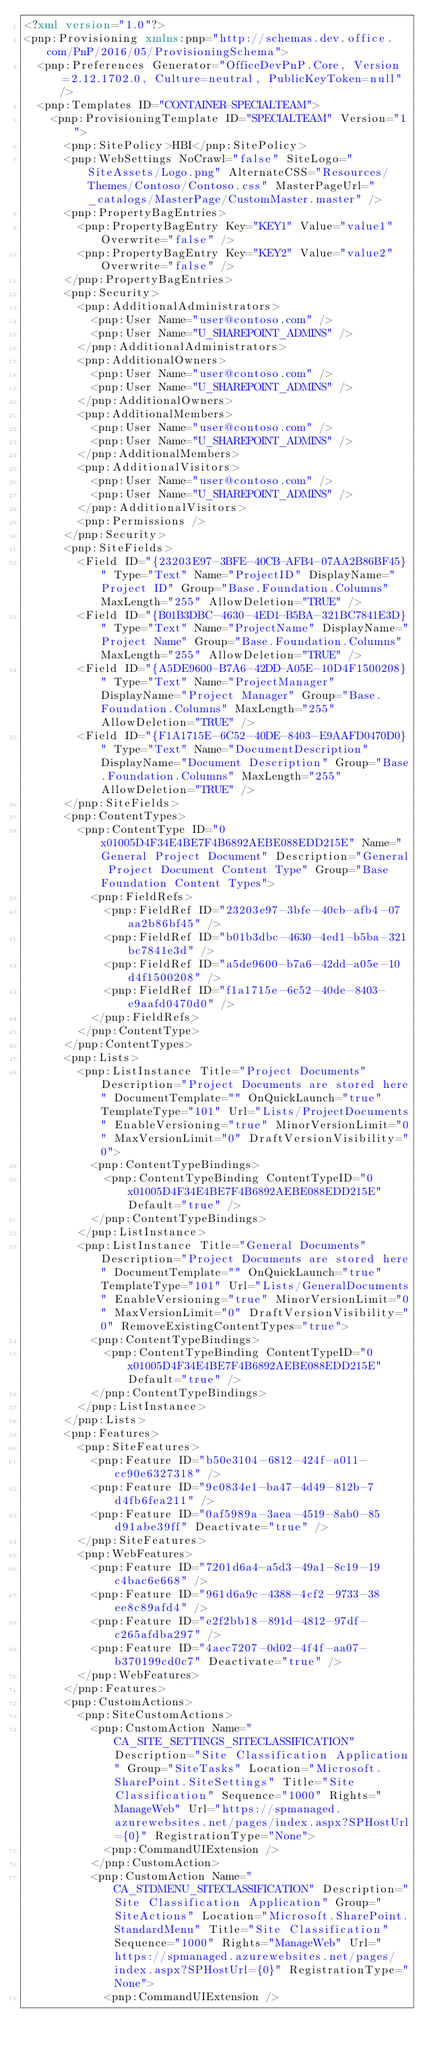<code> <loc_0><loc_0><loc_500><loc_500><_XML_><?xml version="1.0"?>
<pnp:Provisioning xmlns:pnp="http://schemas.dev.office.com/PnP/2016/05/ProvisioningSchema">
  <pnp:Preferences Generator="OfficeDevPnP.Core, Version=2.12.1702.0, Culture=neutral, PublicKeyToken=null" />
  <pnp:Templates ID="CONTAINER-SPECIALTEAM">
    <pnp:ProvisioningTemplate ID="SPECIALTEAM" Version="1">
      <pnp:SitePolicy>HBI</pnp:SitePolicy>
      <pnp:WebSettings NoCrawl="false" SiteLogo="SiteAssets/Logo.png" AlternateCSS="Resources/Themes/Contoso/Contoso.css" MasterPageUrl="_catalogs/MasterPage/CustomMaster.master" />
      <pnp:PropertyBagEntries>
        <pnp:PropertyBagEntry Key="KEY1" Value="value1" Overwrite="false" />
        <pnp:PropertyBagEntry Key="KEY2" Value="value2" Overwrite="false" />
      </pnp:PropertyBagEntries>
      <pnp:Security>
        <pnp:AdditionalAdministrators>
          <pnp:User Name="user@contoso.com" />
          <pnp:User Name="U_SHAREPOINT_ADMINS" />
        </pnp:AdditionalAdministrators>
        <pnp:AdditionalOwners>
          <pnp:User Name="user@contoso.com" />
          <pnp:User Name="U_SHAREPOINT_ADMINS" />
        </pnp:AdditionalOwners>
        <pnp:AdditionalMembers>
          <pnp:User Name="user@contoso.com" />
          <pnp:User Name="U_SHAREPOINT_ADMINS" />
        </pnp:AdditionalMembers>
        <pnp:AdditionalVisitors>
          <pnp:User Name="user@contoso.com" />
          <pnp:User Name="U_SHAREPOINT_ADMINS" />
        </pnp:AdditionalVisitors>
        <pnp:Permissions />
      </pnp:Security>
      <pnp:SiteFields>
        <Field ID="{23203E97-3BFE-40CB-AFB4-07AA2B86BF45}" Type="Text" Name="ProjectID" DisplayName="Project ID" Group="Base.Foundation.Columns" MaxLength="255" AllowDeletion="TRUE" />
        <Field ID="{B01B3DBC-4630-4ED1-B5BA-321BC7841E3D}" Type="Text" Name="ProjectName" DisplayName="Project Name" Group="Base.Foundation.Columns" MaxLength="255" AllowDeletion="TRUE" />
        <Field ID="{A5DE9600-B7A6-42DD-A05E-10D4F1500208}" Type="Text" Name="ProjectManager" DisplayName="Project Manager" Group="Base.Foundation.Columns" MaxLength="255" AllowDeletion="TRUE" />
        <Field ID="{F1A1715E-6C52-40DE-8403-E9AAFD0470D0}" Type="Text" Name="DocumentDescription" DisplayName="Document Description" Group="Base.Foundation.Columns" MaxLength="255" AllowDeletion="TRUE" />
      </pnp:SiteFields>
      <pnp:ContentTypes>
        <pnp:ContentType ID="0x01005D4F34E4BE7F4B6892AEBE088EDD215E" Name="General Project Document" Description="General Project Document Content Type" Group="Base Foundation Content Types">
          <pnp:FieldRefs>
            <pnp:FieldRef ID="23203e97-3bfe-40cb-afb4-07aa2b86bf45" />
            <pnp:FieldRef ID="b01b3dbc-4630-4ed1-b5ba-321bc7841e3d" />
            <pnp:FieldRef ID="a5de9600-b7a6-42dd-a05e-10d4f1500208" />
            <pnp:FieldRef ID="f1a1715e-6c52-40de-8403-e9aafd0470d0" />
          </pnp:FieldRefs>
        </pnp:ContentType>
      </pnp:ContentTypes>
      <pnp:Lists>
        <pnp:ListInstance Title="Project Documents" Description="Project Documents are stored here" DocumentTemplate="" OnQuickLaunch="true" TemplateType="101" Url="Lists/ProjectDocuments" EnableVersioning="true" MinorVersionLimit="0" MaxVersionLimit="0" DraftVersionVisibility="0">
          <pnp:ContentTypeBindings>
            <pnp:ContentTypeBinding ContentTypeID="0x01005D4F34E4BE7F4B6892AEBE088EDD215E" Default="true" />
          </pnp:ContentTypeBindings>
        </pnp:ListInstance>
        <pnp:ListInstance Title="General Documents" Description="Project Documents are stored here" DocumentTemplate="" OnQuickLaunch="true" TemplateType="101" Url="Lists/GeneralDocuments" EnableVersioning="true" MinorVersionLimit="0" MaxVersionLimit="0" DraftVersionVisibility="0" RemoveExistingContentTypes="true">
          <pnp:ContentTypeBindings>
            <pnp:ContentTypeBinding ContentTypeID="0x01005D4F34E4BE7F4B6892AEBE088EDD215E" Default="true" />
          </pnp:ContentTypeBindings>
        </pnp:ListInstance>
      </pnp:Lists>
      <pnp:Features>
        <pnp:SiteFeatures>
          <pnp:Feature ID="b50e3104-6812-424f-a011-cc90e6327318" />
          <pnp:Feature ID="9c0834e1-ba47-4d49-812b-7d4fb6fea211" />
          <pnp:Feature ID="0af5989a-3aea-4519-8ab0-85d91abe39ff" Deactivate="true" />
        </pnp:SiteFeatures>
        <pnp:WebFeatures>
          <pnp:Feature ID="7201d6a4-a5d3-49a1-8c19-19c4bac6e668" />
          <pnp:Feature ID="961d6a9c-4388-4cf2-9733-38ee8c89afd4" />
          <pnp:Feature ID="e2f2bb18-891d-4812-97df-c265afdba297" />
          <pnp:Feature ID="4aec7207-0d02-4f4f-aa07-b370199cd0c7" Deactivate="true" />
        </pnp:WebFeatures>
      </pnp:Features>
      <pnp:CustomActions>
        <pnp:SiteCustomActions>
          <pnp:CustomAction Name="CA_SITE_SETTINGS_SITECLASSIFICATION" Description="Site Classification Application" Group="SiteTasks" Location="Microsoft.SharePoint.SiteSettings" Title="Site Classification" Sequence="1000" Rights="ManageWeb" Url="https://spmanaged.azurewebsites.net/pages/index.aspx?SPHostUrl={0}" RegistrationType="None">
            <pnp:CommandUIExtension />
          </pnp:CustomAction>
          <pnp:CustomAction Name="CA_STDMENU_SITECLASSIFICATION" Description="Site Classification Application" Group="SiteActions" Location="Microsoft.SharePoint.StandardMenu" Title="Site Classification" Sequence="1000" Rights="ManageWeb" Url="https://spmanaged.azurewebsites.net/pages/index.aspx?SPHostUrl={0}" RegistrationType="None">
            <pnp:CommandUIExtension /></code> 